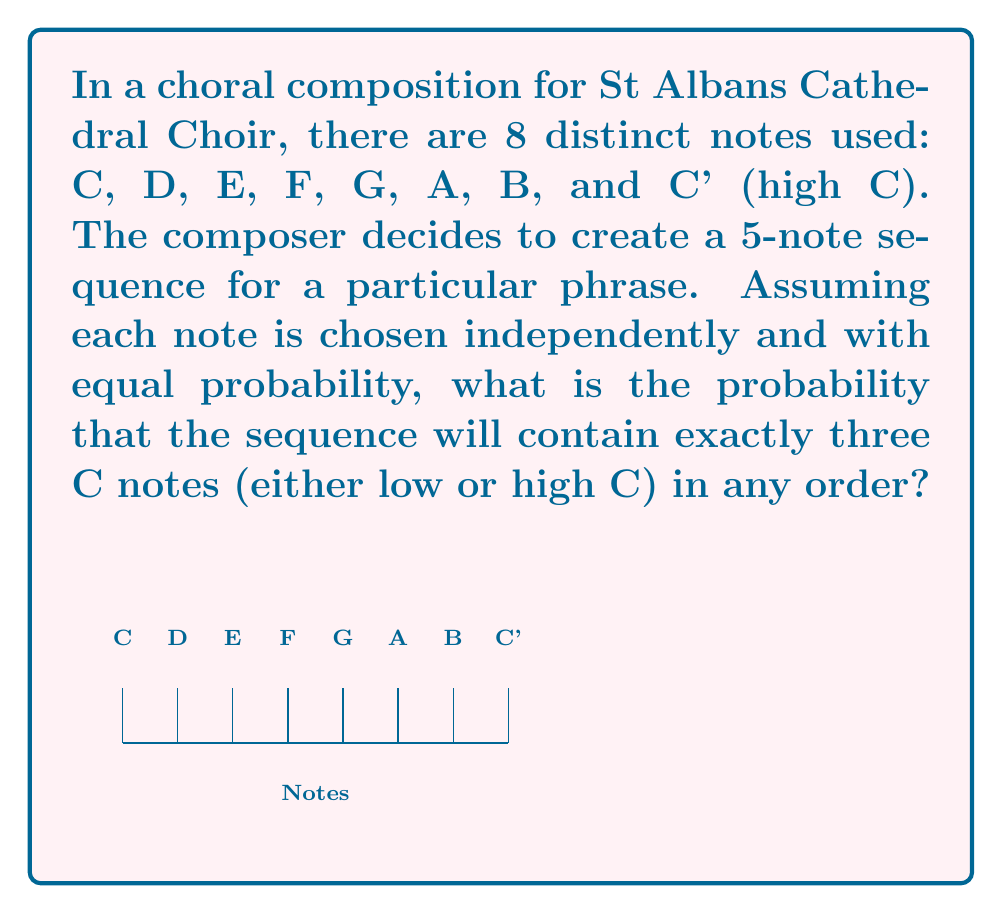Could you help me with this problem? Let's approach this step-by-step:

1) First, we need to calculate the probability of choosing a C (either low or high) in a single selection:
   $P(\text{C or C'}) = \frac{2}{8} = \frac{1}{4}$

2) The probability of not choosing a C is:
   $P(\text{not C}) = 1 - \frac{1}{4} = \frac{3}{4}$

3) We want exactly three C notes in a sequence of 5. This can be modeled as a binomial probability problem.

4) The number of ways to arrange 3 C notes in a 5-note sequence is $\binom{5}{3} = 10$

5) The probability of this specific arrangement (3 C's and 2 non-C's) is:
   $P(\text{3 C's and 2 non-C's}) = (\frac{1}{4})^3 \cdot (\frac{3}{4})^2$

6) Combining steps 4 and 5, we get the total probability:
   $$P(\text{exactly 3 C's in 5 notes}) = \binom{5}{3} \cdot (\frac{1}{4})^3 \cdot (\frac{3}{4})^2$$

7) Calculating:
   $$P = 10 \cdot (\frac{1}{64}) \cdot (\frac{9}{16}) = \frac{90}{1024} = \frac{45}{512} \approx 0.0879$$
Answer: $\frac{45}{512}$ 